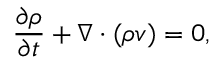<formula> <loc_0><loc_0><loc_500><loc_500>\frac { \partial \rho } { \partial t } + \nabla \cdot ( \rho v ) = 0 ,</formula> 